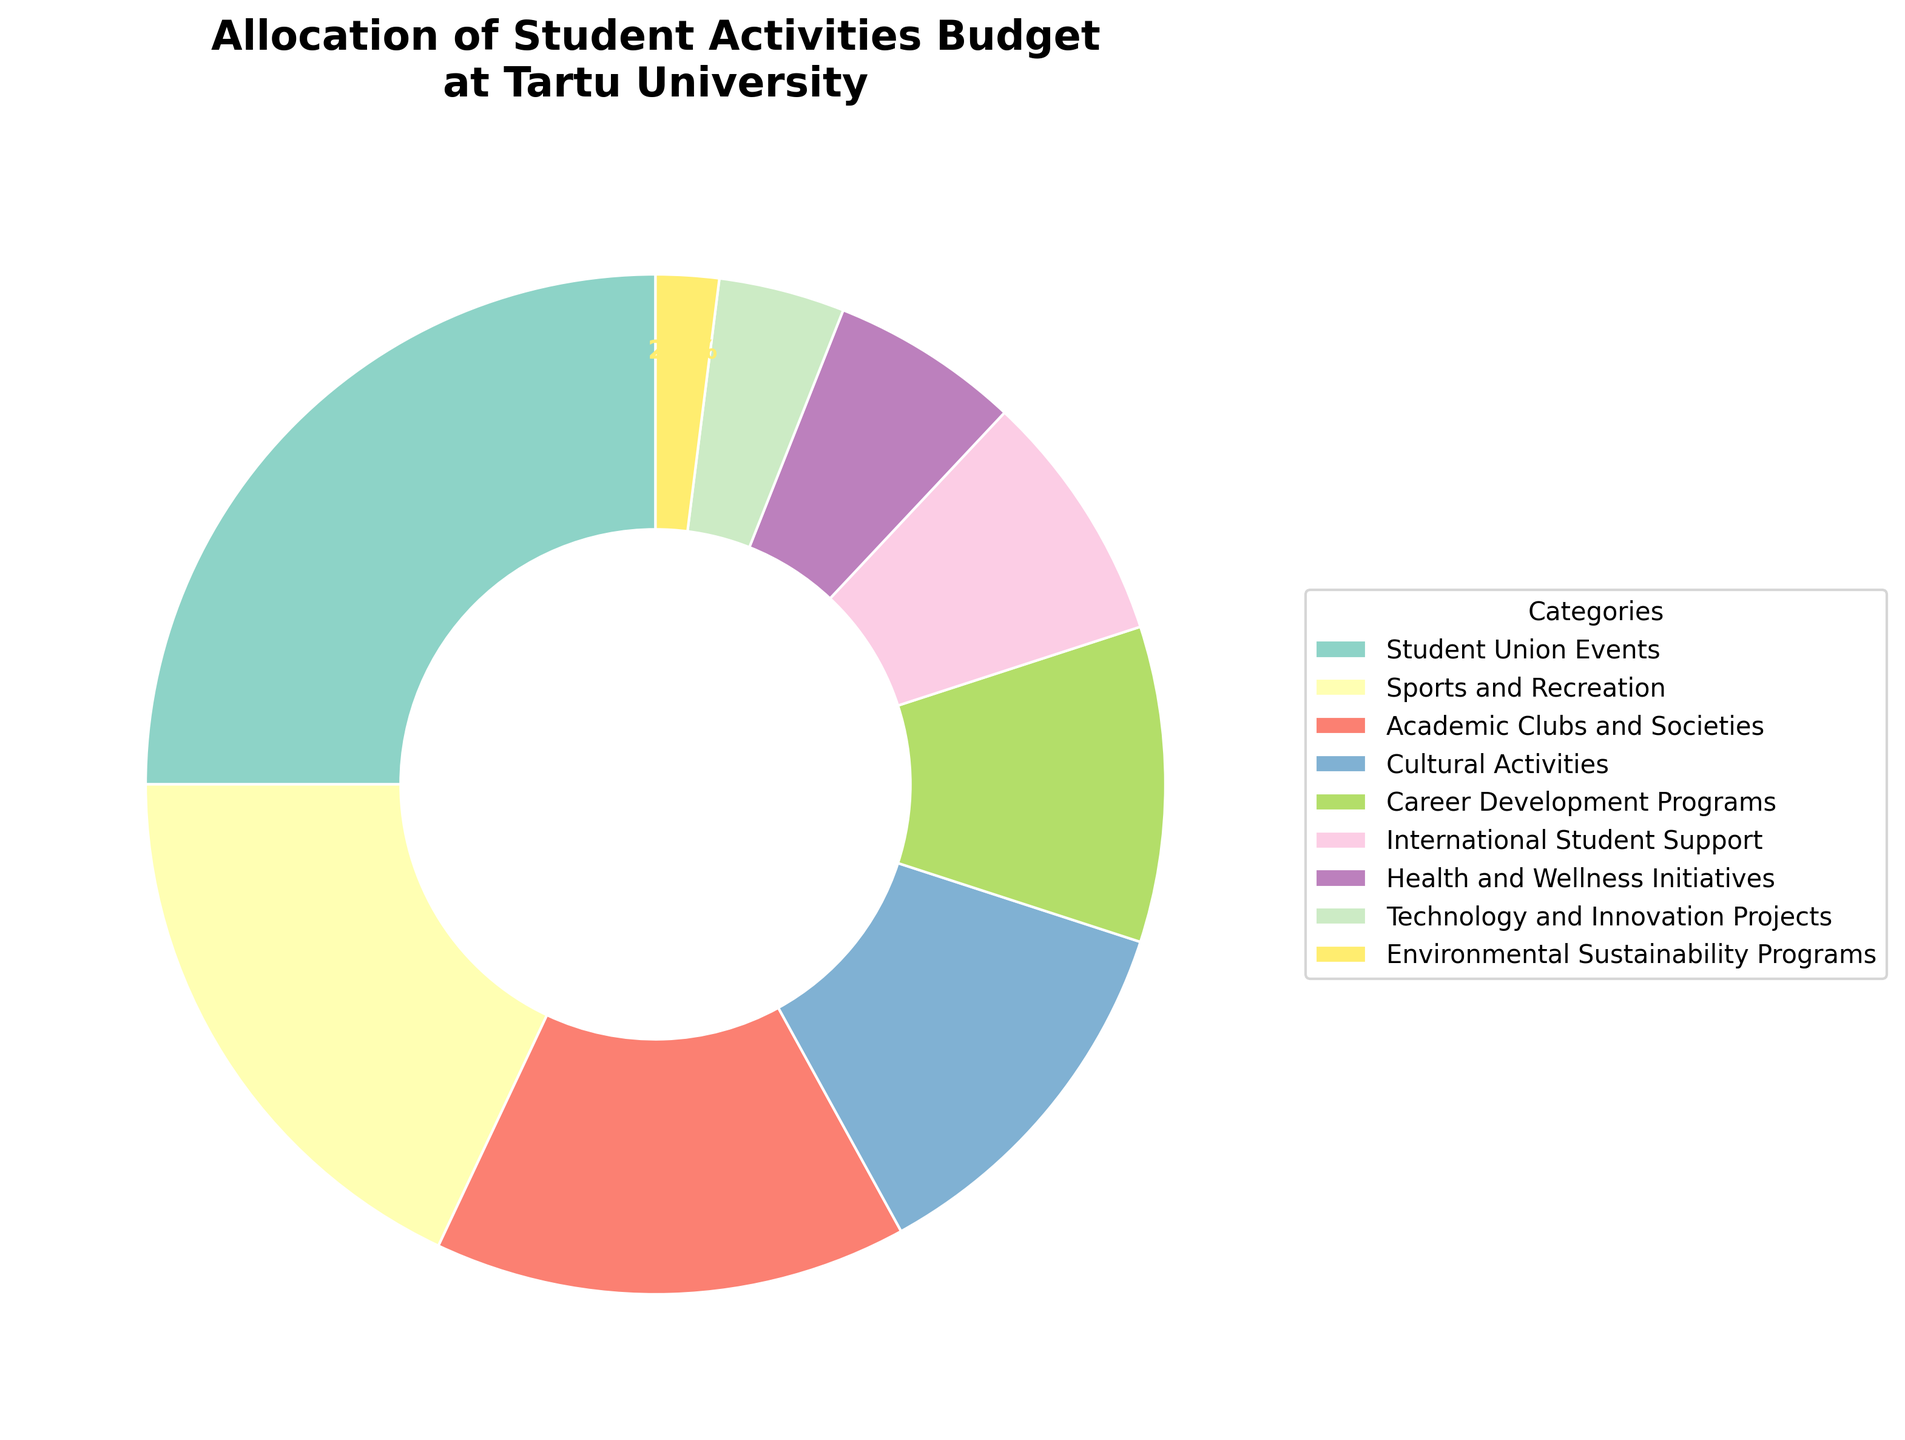Which category has the highest budget allocation? The category with the highest percentage slice in the pie chart is the one with the highest budget allocation. Student Union Events stands out with the largest slice, indicated at 25%.
Answer: Student Union Events Which category has the second smallest budget allocation, and what is its percentage? To identify the second smallest allocation, look for the second smallest slice in the pie chart. Health and Wellness Initiatives (6%) is slightly larger than Environmental Sustainability Programs (2%).
Answer: Health and Wellness Initiatives, 6% What is the combined percentage allocation for Sports and Recreation and Career Development Programs? Sum the percentages for Sports and Recreation (18%) and Career Development Programs (10%). Therefore, 18 + 10 = 28%.
Answer: 28% Is the percentage allocated to Academic Clubs and Societies greater than that of Cultural Activities? Compare the slices of Academic Clubs and Societies (15%) and Cultural Activities (12%). The slice for Academic Clubs and Societies is larger.
Answer: Yes What is the difference in percentage allocation between International Student Support and Technology and Innovation Projects? Subtract the percentage of Technology and Innovation Projects (4%) from that of International Student Support (8%). 8 - 4 = 4%.
Answer: 4% If we combine the percentages for Cultural Activities, Health and Wellness Initiatives, and Environmental Sustainability Programs, what is the total percentage? Add the percentages for Cultural Activities (12%), Health and Wellness Initiatives (6%), and Environmental Sustainability Programs (2%). 12 + 6 + 2 = 20%.
Answer: 20% Which category corresponding to the green-colored slice in the pie chart? Look at the pie chart and identify the category allocated the green-colored slice. This slice is representative of Career Development Programs.
Answer: Career Development Programs Compared to the total allocation for Academic Clubs and Societies and Cultural Activities, which is greater: the total percentage for Sports and Recreation or the combined allocation of the first two categories? First, sum the percentages of Academic Clubs and Societies (15%) and Cultural Activities (12%): 15 + 12 = 27%. Now, compare this to Sports and Recreation (18%). 27% is greater than 18%.
Answer: Combined allocation of Academic Clubs and Societies and Cultural Activities Which category's allocation is represented by the slice that is halfway between the smallest and largest slices in the pie chart? Identify Environmental Sustainability Programs (2%) as the smallest and Student Union Events (25%) as the largest. The halfway allocation is represented by Health and Wellness Initiatives (6%) since it sits reasonably close to the midpoint.
Answer: Health and Wellness Initiatives How much smaller is the allocation for Technology and Innovation Projects compared to the allocation for Academic Clubs and Societies? Subtract the percentage of Technology and Innovation Projects (4%) from that of Academic Clubs and Societies (15%). 15 - 4 = 11%.
Answer: 11% 